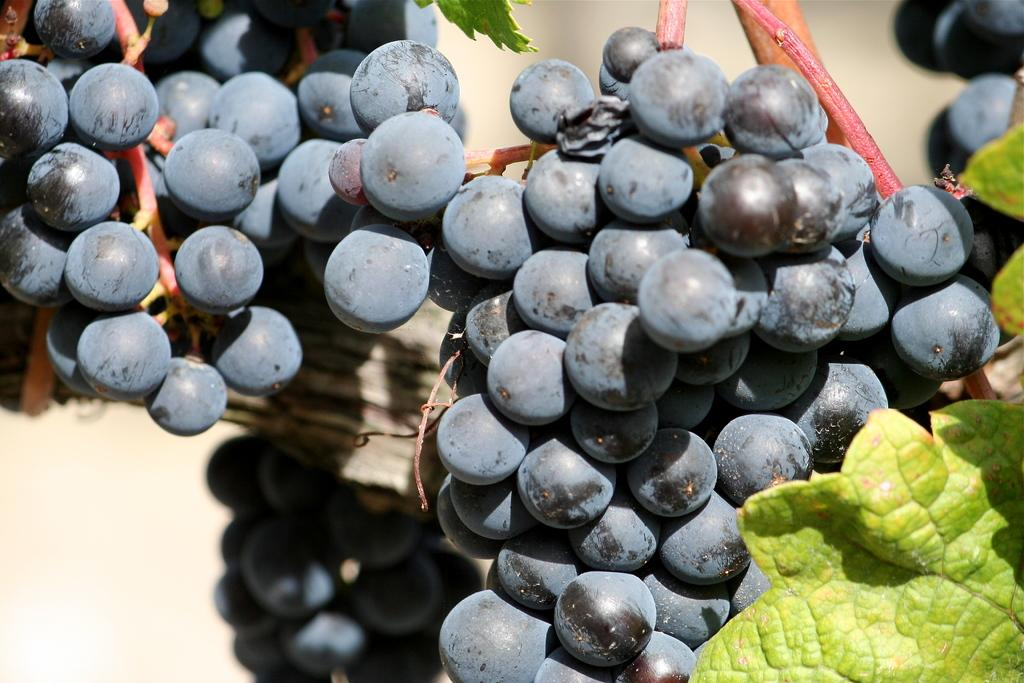What type of fruit is present in the image? There are grapes in the image. What else can be seen in the image besides the grapes? There are leaves in the image. What type of meat is being sold by the beggar in the image? There is no beggar or meat present in the image; it only features grapes and leaves. 